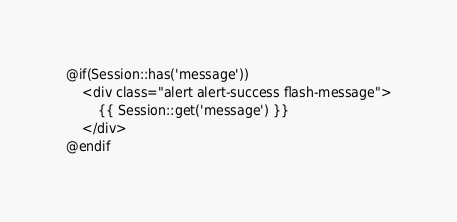Convert code to text. <code><loc_0><loc_0><loc_500><loc_500><_PHP_>@if(Session::has('message'))
    <div class="alert alert-success flash-message">
        {{ Session::get('message') }}
    </div>
@endif</code> 